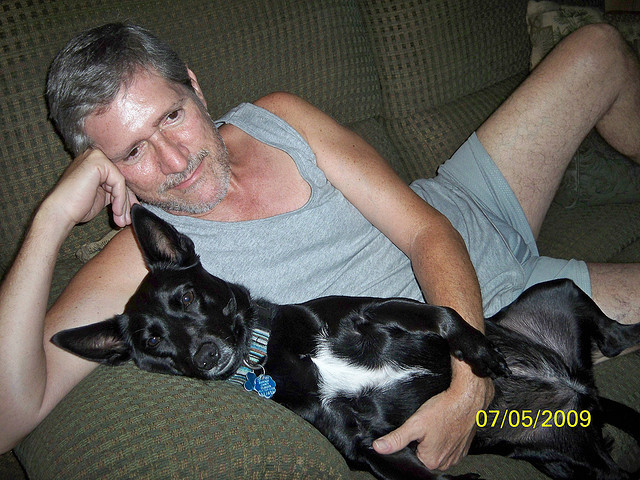<image>What breed is the dog? I am not sure about the breed of the dog. It could be a black lab, terrier, lab, doberman, schnauzer or a lab mix. What breed is the dog? I am not sure about the breed of the dog. It can be a black lab, terrier, lab, doberman, schnauzer, or lab mix. 